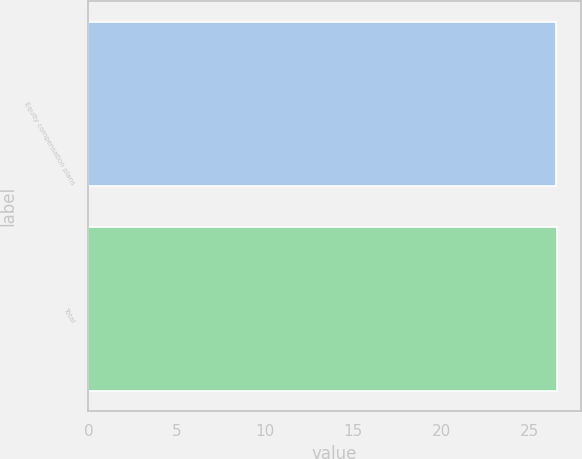Convert chart to OTSL. <chart><loc_0><loc_0><loc_500><loc_500><bar_chart><fcel>Equity compensation plans<fcel>Total<nl><fcel>26.49<fcel>26.59<nl></chart> 